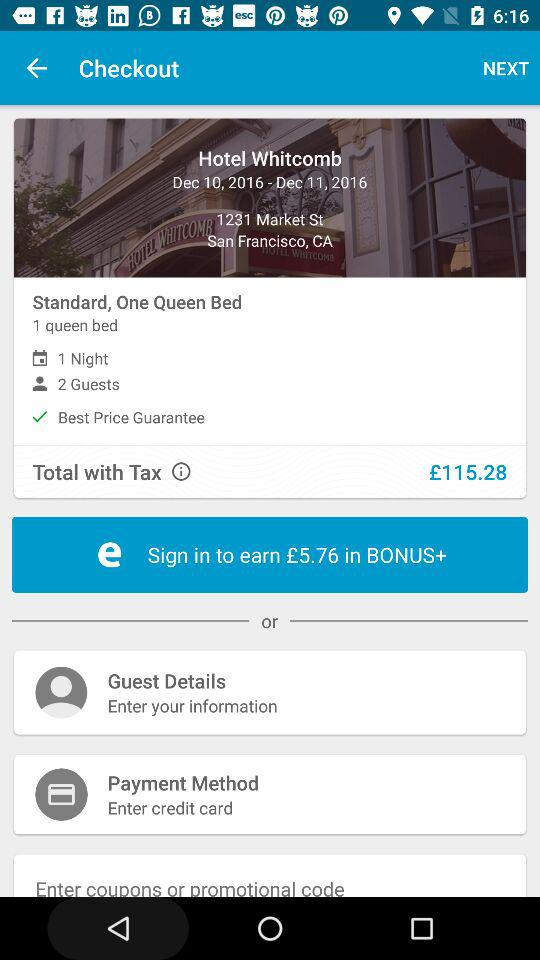What is the currency for the prices? The currency for the prices is the pound. 